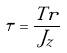Convert formula to latex. <formula><loc_0><loc_0><loc_500><loc_500>\tau = \frac { T r } { J _ { z } }</formula> 